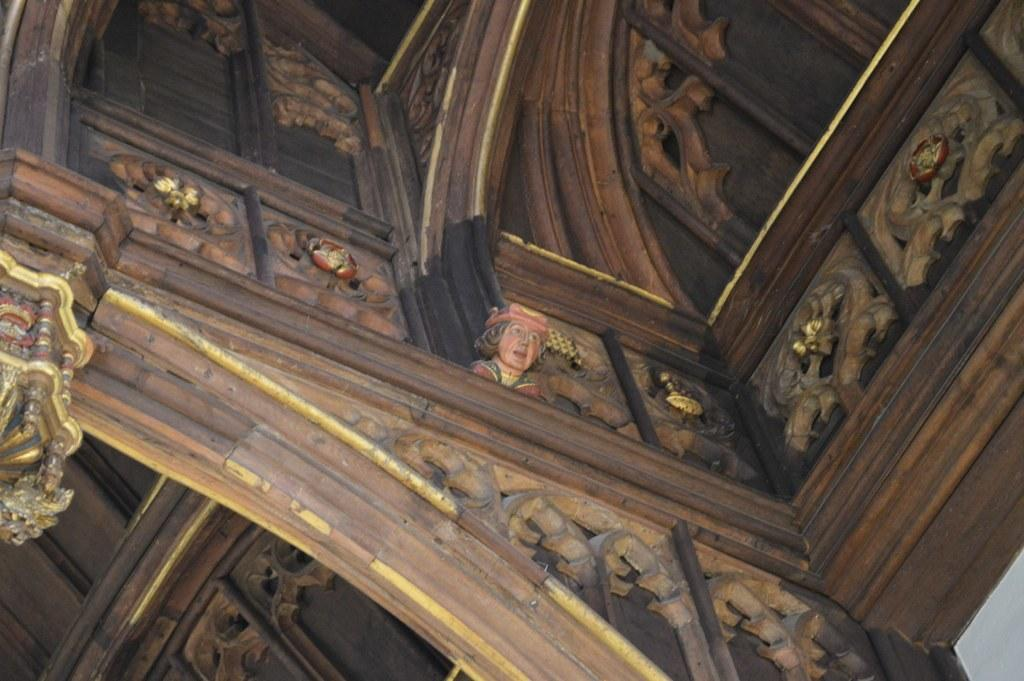What type of location is depicted in the image? The image shows an inside view of a building. What can be seen in the middle of the image? There is a sculpture in the middle of the image. How many giants are visible in the image? There are no giants present in the image. What type of nail is being used to hold the sculpture together? The image does not provide information about the materials or construction of the sculpture, so it is not possible to determine what type of nail is being used. 